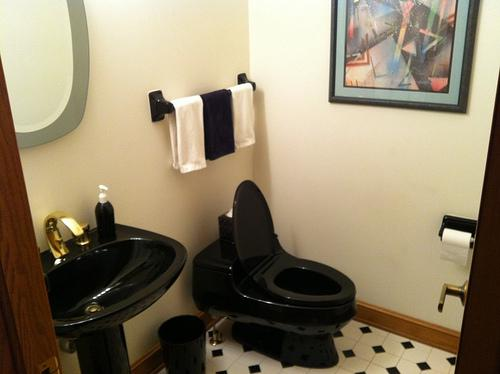Question: where are there towels?
Choices:
A. On a rack above the commode.
B. In the laundry.
C. On the cabinet.
D. In the hamper.
Answer with the letter. Answer: A Question: what is the pattern on the floor?
Choices:
A. Solid color.
B. Striped carpet.
C. Diamond shaped area rug.
D. Black diamonds against a white background.
Answer with the letter. Answer: D Question: what shape is the mirror?
Choices:
A. Square.
B. Oval.
C. Rectangle.
D. Round.
Answer with the letter. Answer: B Question: what is unusual here?
Choices:
A. There is carpet.
B. There are bars on the windows.
C. The dog is on the table.
D. Bathroom fixtures are not often black.
Answer with the letter. Answer: D 